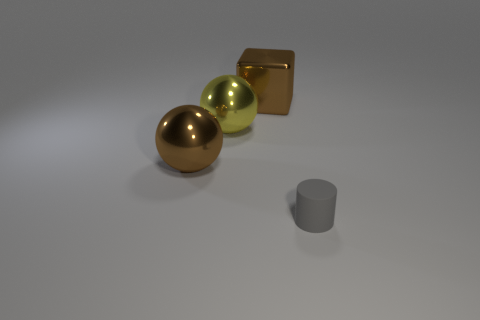What can you infer about the surface the objects are on? The surface appears to be smooth and even, with a matte finish that softly reflects the objects. Its muted tone suggests it's meant to be nondescript, focusing attention on the objects themselves. 